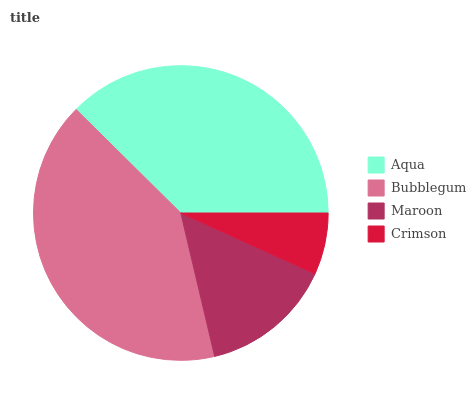Is Crimson the minimum?
Answer yes or no. Yes. Is Bubblegum the maximum?
Answer yes or no. Yes. Is Maroon the minimum?
Answer yes or no. No. Is Maroon the maximum?
Answer yes or no. No. Is Bubblegum greater than Maroon?
Answer yes or no. Yes. Is Maroon less than Bubblegum?
Answer yes or no. Yes. Is Maroon greater than Bubblegum?
Answer yes or no. No. Is Bubblegum less than Maroon?
Answer yes or no. No. Is Aqua the high median?
Answer yes or no. Yes. Is Maroon the low median?
Answer yes or no. Yes. Is Bubblegum the high median?
Answer yes or no. No. Is Crimson the low median?
Answer yes or no. No. 